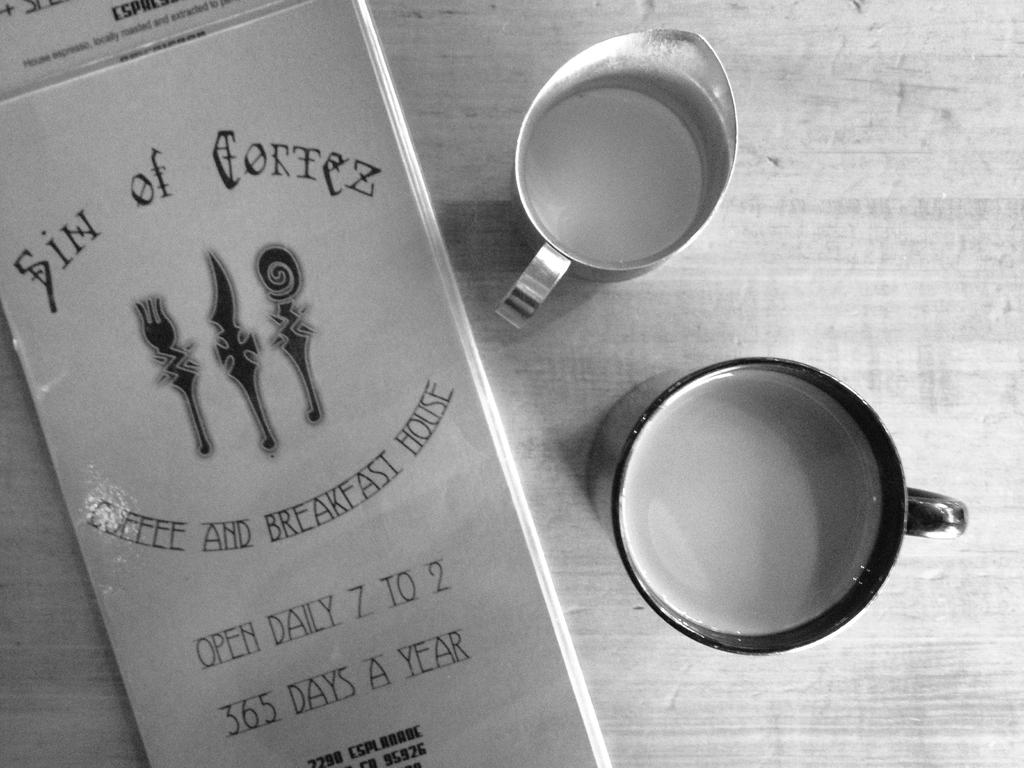How many cups are visible in the image? There are two cups in the image. What is inside the cups? The cups contain liquids. What object is present on the table in the image? There is a book on a table in the image. What type of glass is the book made of in the image? The book is not made of glass; it is made of paper and has a cover. Can you see any fights happening in the image? There is no fight depicted in the image; it features two cups containing liquids and a book on a table. 